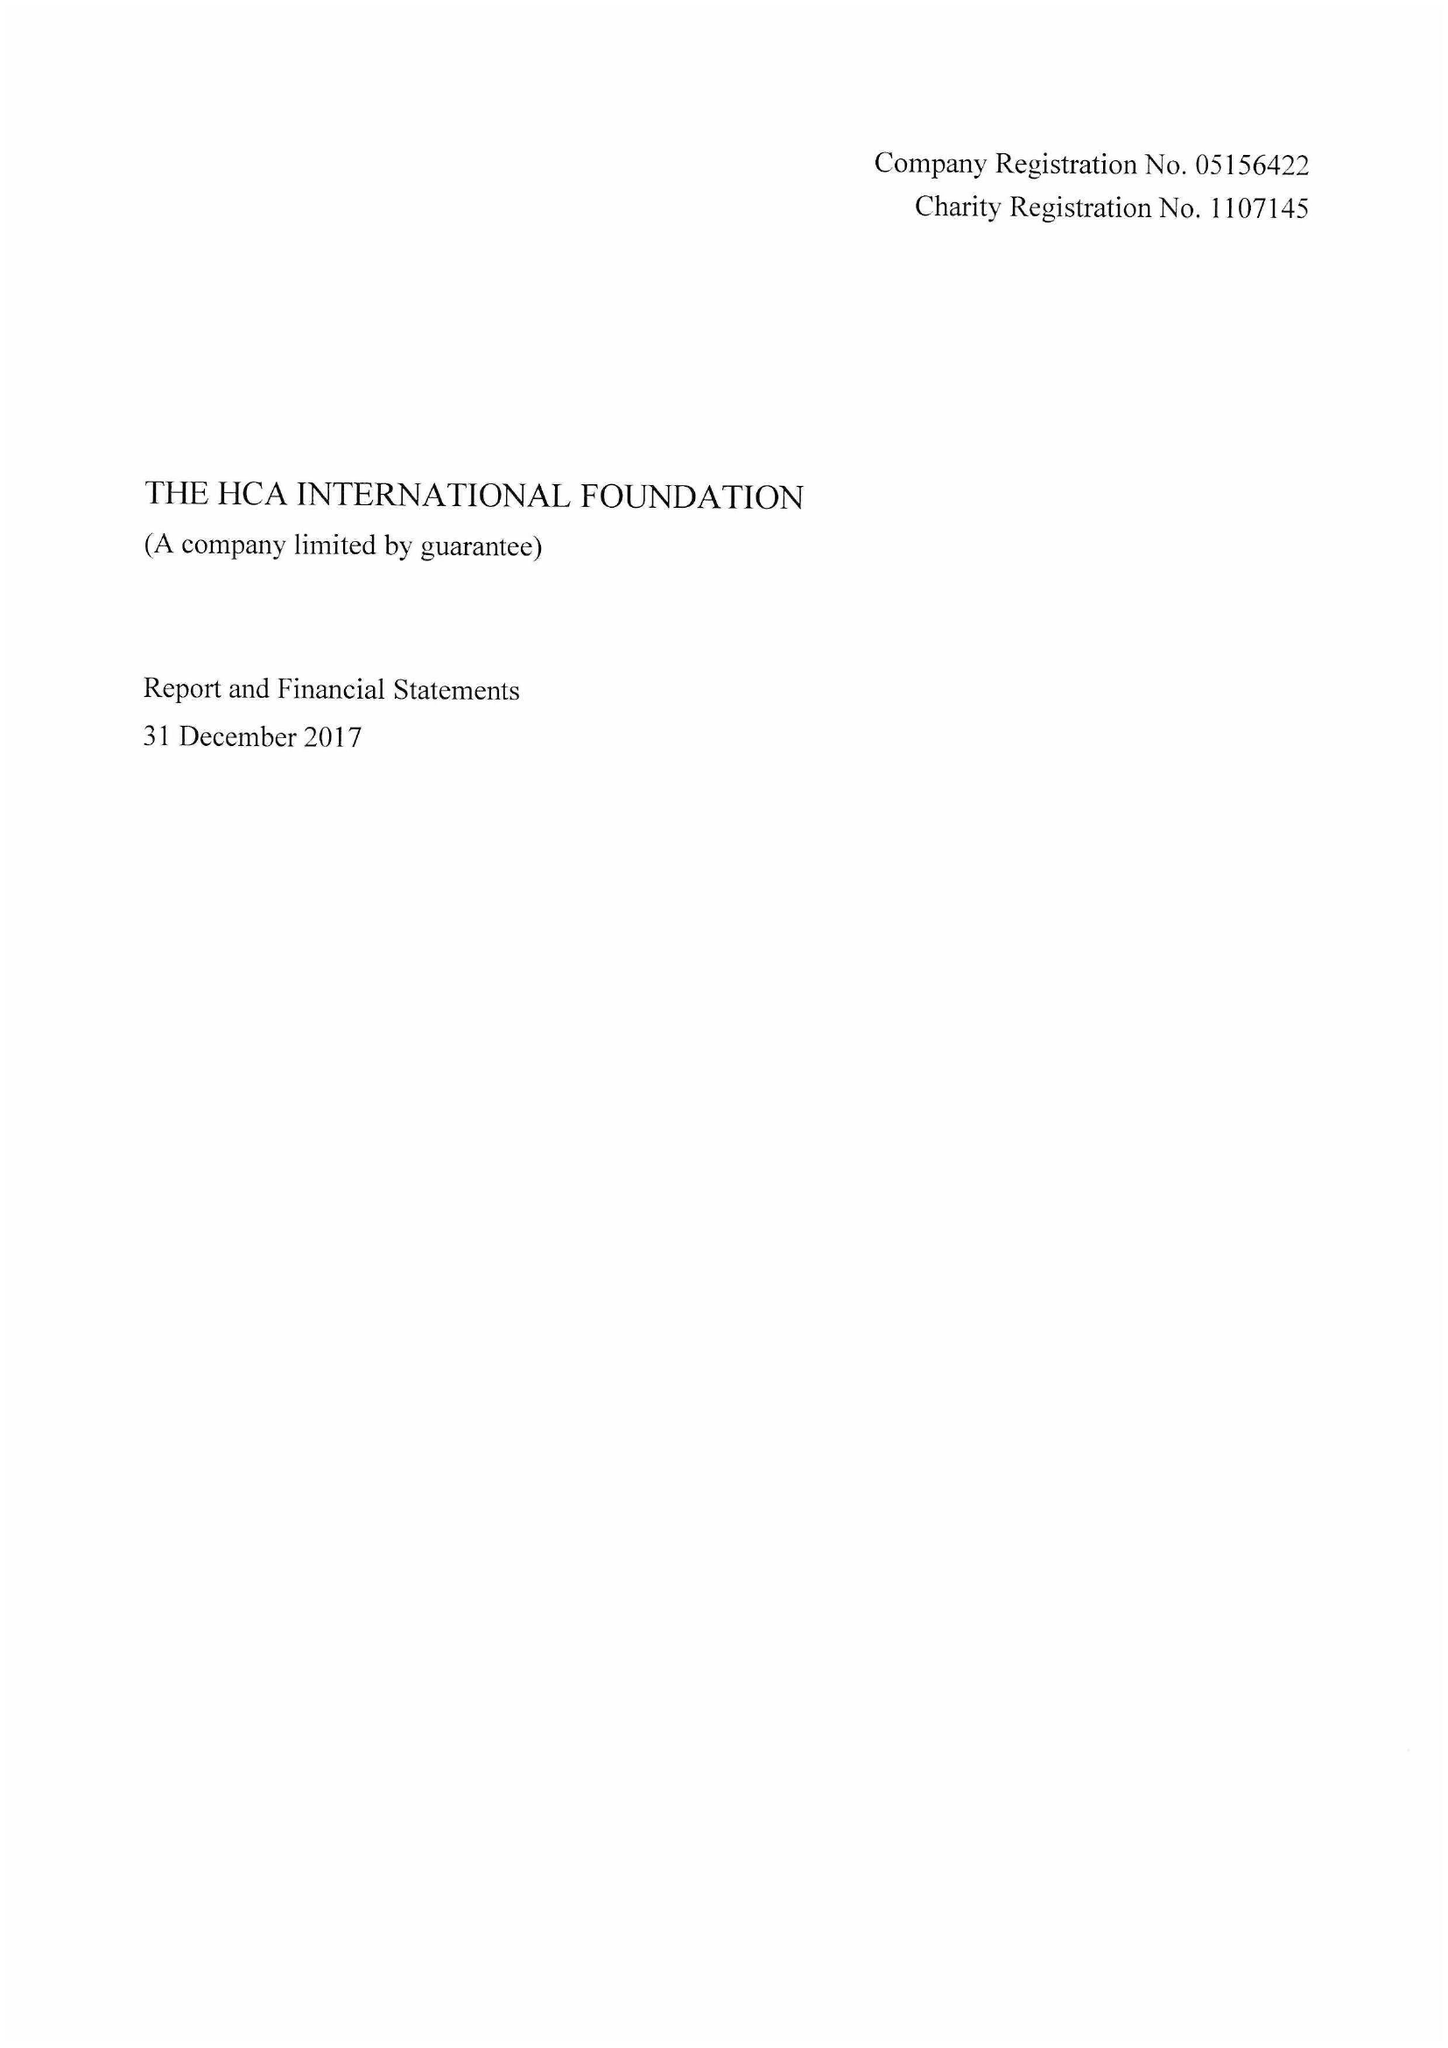What is the value for the address__postcode?
Answer the question using a single word or phrase. NW1 6JQ 